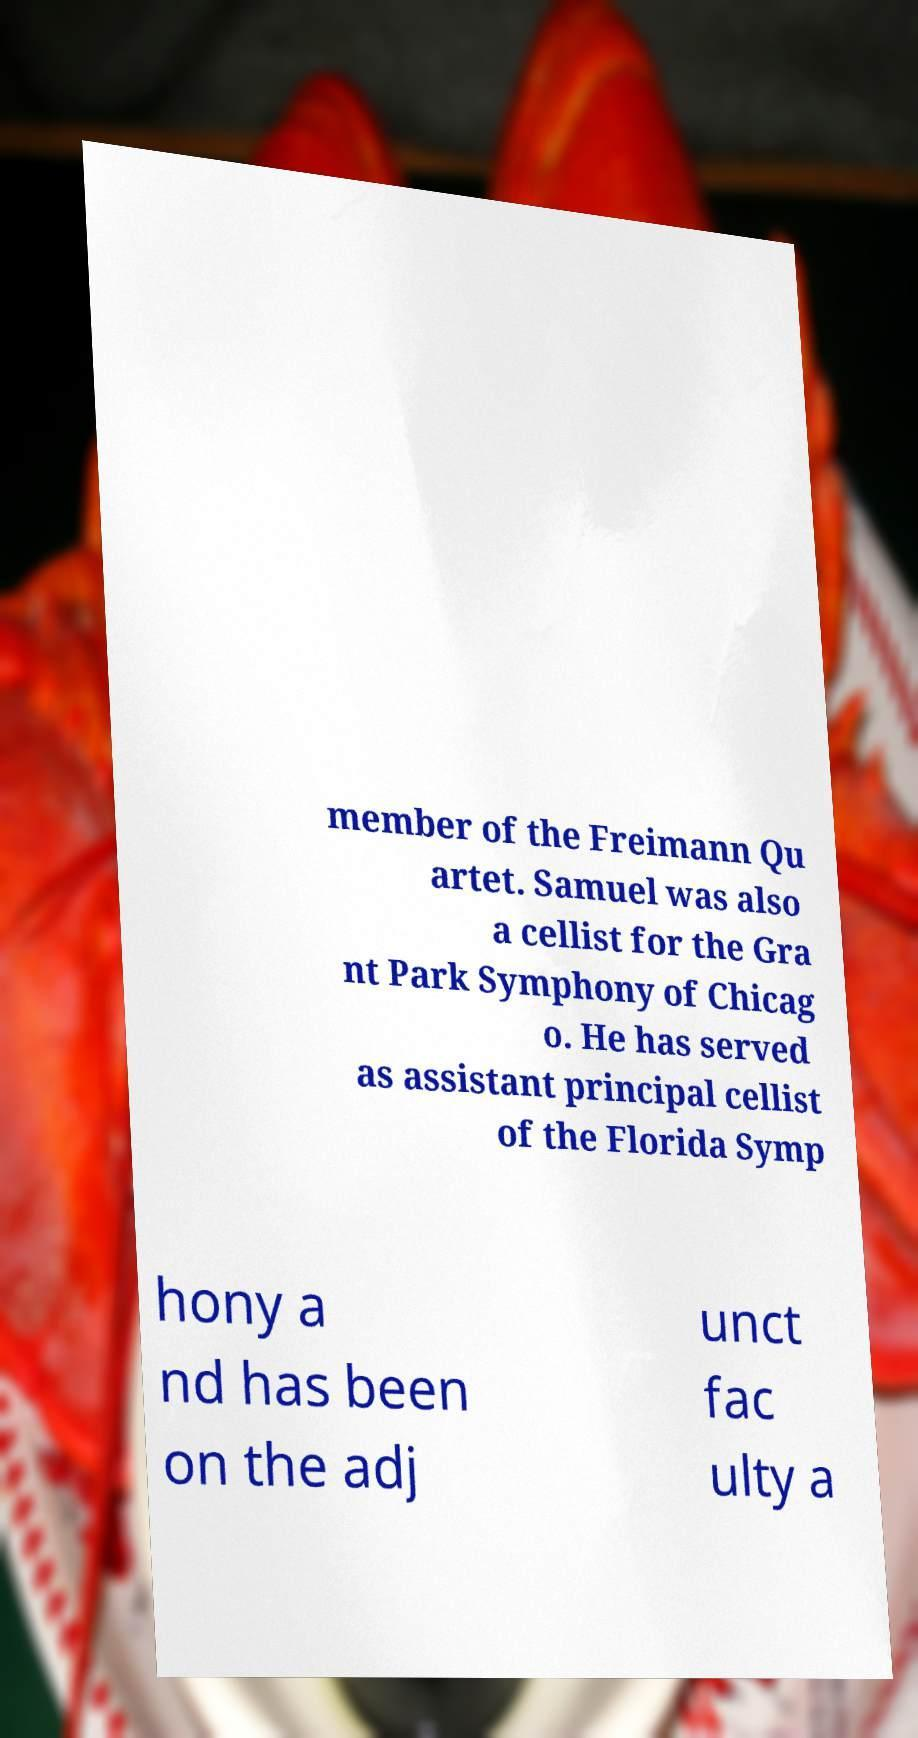Could you assist in decoding the text presented in this image and type it out clearly? member of the Freimann Qu artet. Samuel was also a cellist for the Gra nt Park Symphony of Chicag o. He has served as assistant principal cellist of the Florida Symp hony a nd has been on the adj unct fac ulty a 